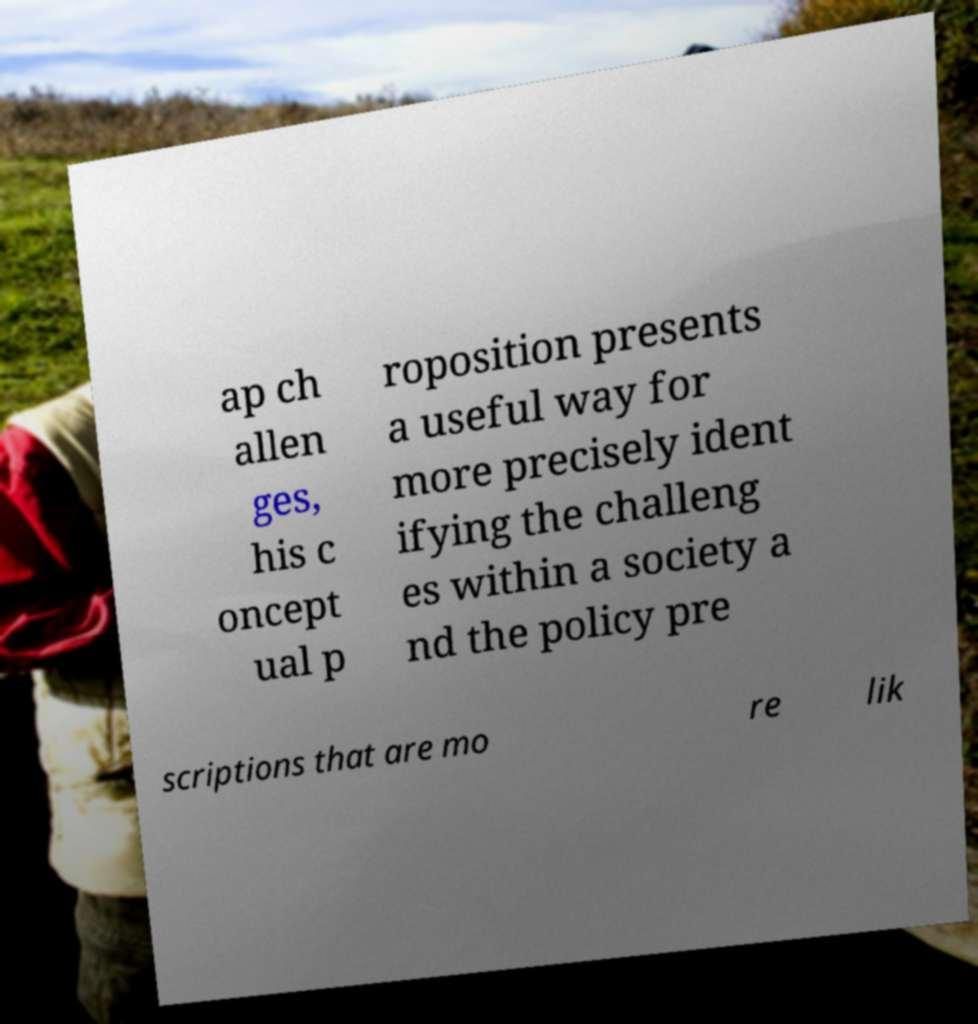There's text embedded in this image that I need extracted. Can you transcribe it verbatim? ap ch allen ges, his c oncept ual p roposition presents a useful way for more precisely ident ifying the challeng es within a society a nd the policy pre scriptions that are mo re lik 